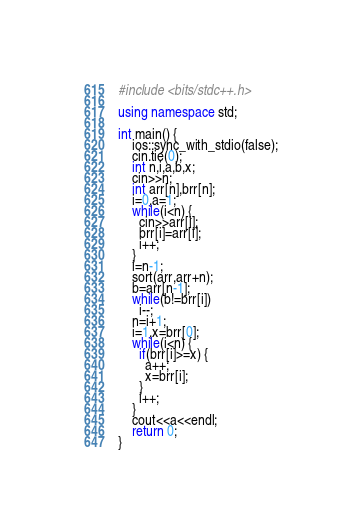<code> <loc_0><loc_0><loc_500><loc_500><_C++_>#include <bits/stdc++.h> 

using namespace std;

int main() {
    ios::sync_with_stdio(false);
    cin.tie(0);
    int n,i,a,b,x;
    cin>>n;
    int arr[n],brr[n];
    i=0,a=1;
    while(i<n) {
      cin>>arr[i];
      brr[i]=arr[i];
      i++;
    }
    i=n-1;
    sort(arr,arr+n);
    b=arr[n-1];
    while(b!=brr[i])
      i--;
    n=i+1;
    i=1,x=brr[0];
    while(i<n) {
      if(brr[i]>=x) {
        a++;
        x=brr[i];
      }
      i++;
    }
    cout<<a<<endl;
    return 0;
}
</code> 